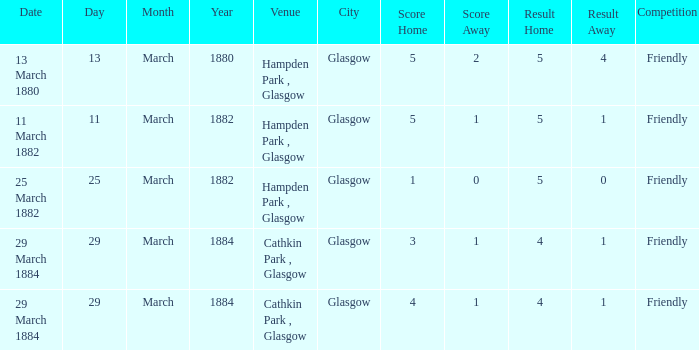Which item has a score of 5-1? 5-1. 